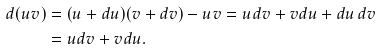<formula> <loc_0><loc_0><loc_500><loc_500>d ( u v ) & = ( u + d u ) ( v + d v ) - u v = u d v + v d u + d u \, d v \\ & = u d v + v d u .</formula> 